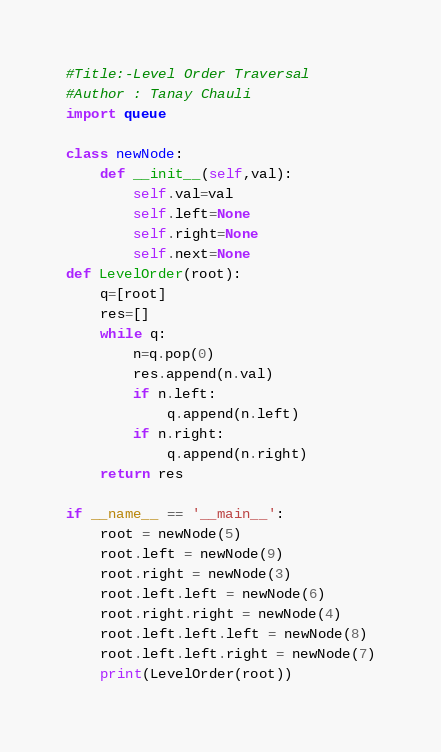<code> <loc_0><loc_0><loc_500><loc_500><_Python_>#Title:-Level Order Traversal
#Author : Tanay Chauli
import queue

class newNode:
    def __init__(self,val):
        self.val=val
        self.left=None
        self.right=None
        self.next=None
def LevelOrder(root):
    q=[root]
    res=[]
    while q:
        n=q.pop(0)
        res.append(n.val)
        if n.left:
            q.append(n.left)
        if n.right:
            q.append(n.right)
    return res

if __name__ == '__main__':
    root = newNode(5)
    root.left = newNode(9)
    root.right = newNode(3)
    root.left.left = newNode(6)
    root.right.right = newNode(4)
    root.left.left.left = newNode(8)
    root.left.left.right = newNode(7)
    print(LevelOrder(root))
</code> 